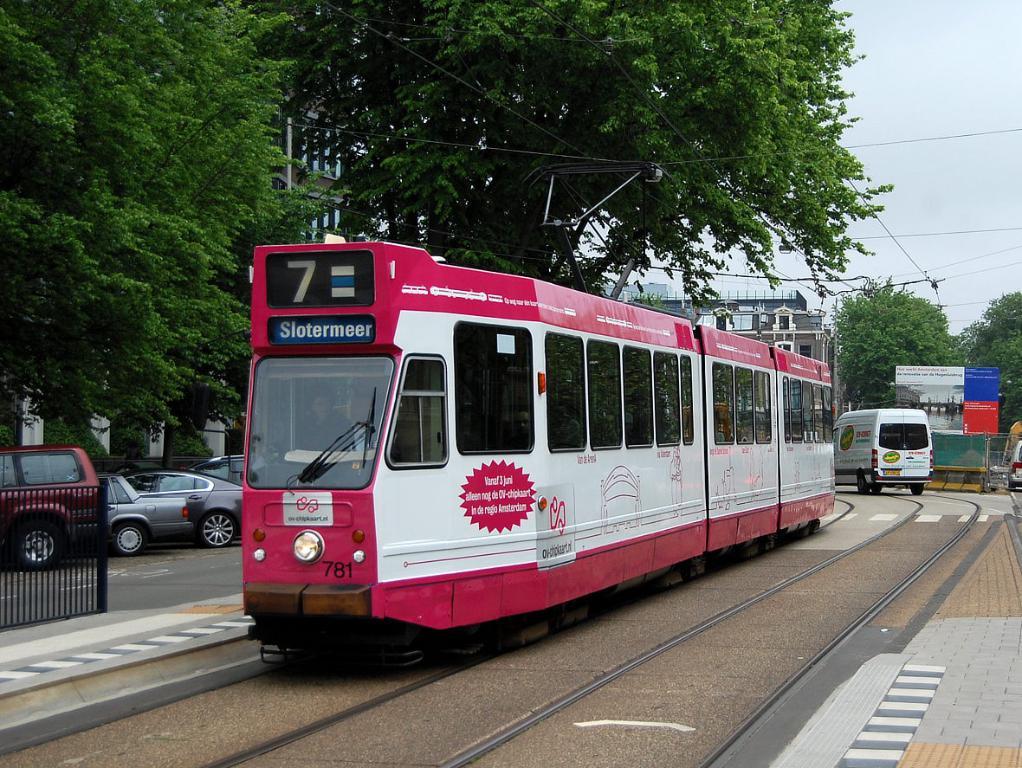What trolley number is this?
Provide a short and direct response. 7. What number is at the bottom front of the trolley?
Your answer should be very brief. 781. 